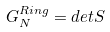Convert formula to latex. <formula><loc_0><loc_0><loc_500><loc_500>G _ { N } ^ { R i n g } = d e t S</formula> 